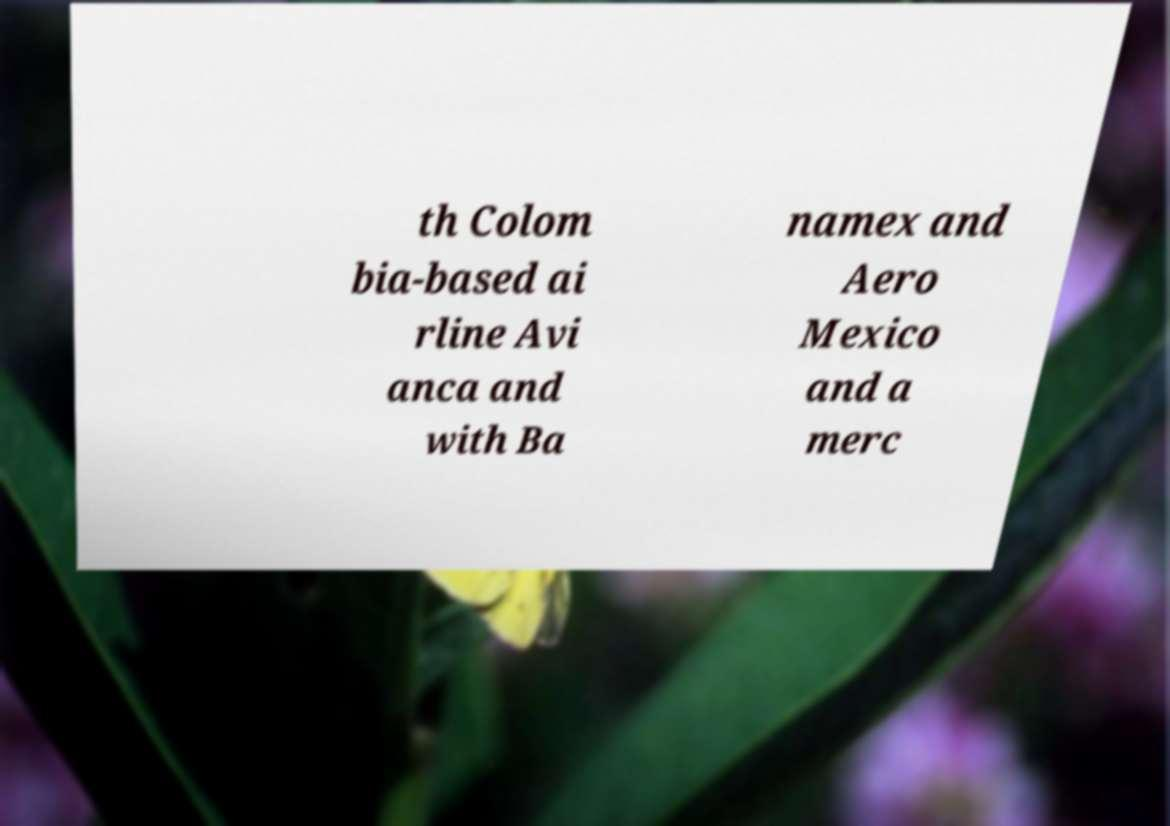Please identify and transcribe the text found in this image. th Colom bia-based ai rline Avi anca and with Ba namex and Aero Mexico and a merc 